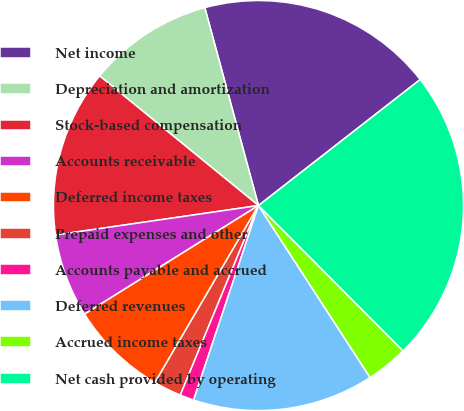Convert chart to OTSL. <chart><loc_0><loc_0><loc_500><loc_500><pie_chart><fcel>Net income<fcel>Depreciation and amortization<fcel>Stock-based compensation<fcel>Accounts receivable<fcel>Deferred income taxes<fcel>Prepaid expenses and other<fcel>Accounts payable and accrued<fcel>Deferred revenues<fcel>Accrued income taxes<fcel>Net cash provided by operating<nl><fcel>18.68%<fcel>9.89%<fcel>13.19%<fcel>6.59%<fcel>7.69%<fcel>2.2%<fcel>1.1%<fcel>14.29%<fcel>3.3%<fcel>23.07%<nl></chart> 